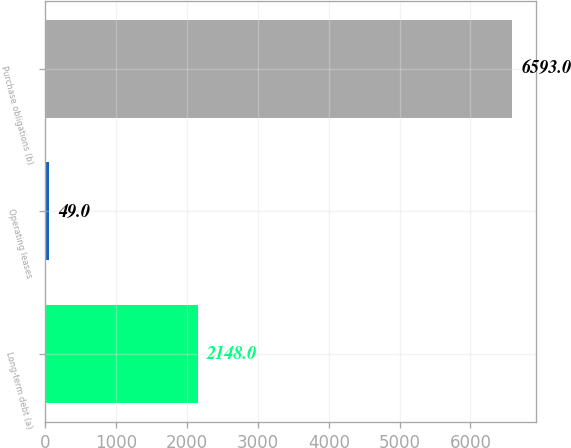Convert chart. <chart><loc_0><loc_0><loc_500><loc_500><bar_chart><fcel>Long-term debt (a)<fcel>Operating leases<fcel>Purchase obligations (b)<nl><fcel>2148<fcel>49<fcel>6593<nl></chart> 